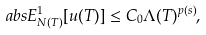<formula> <loc_0><loc_0><loc_500><loc_500>\ a b s { E ^ { 1 } _ { N ( T ) } [ u ( T ) ] } \leq C _ { 0 } \Lambda ( T ) ^ { p ( s ) } ,</formula> 